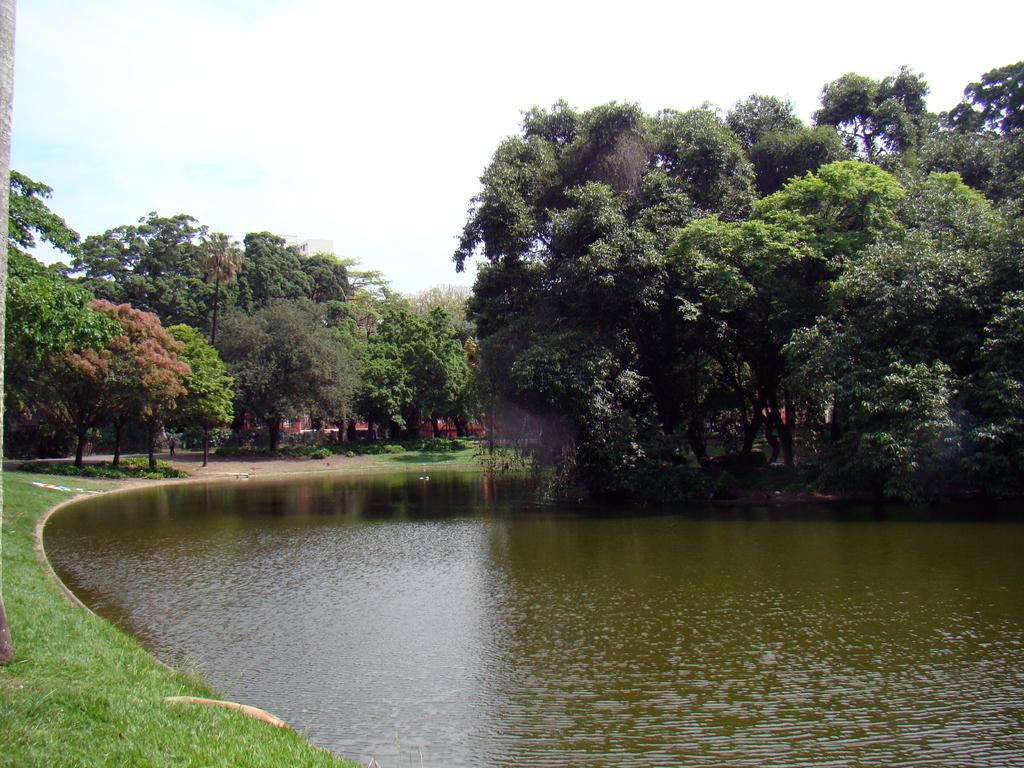What is one of the natural elements visible in the image? Water is visible in the image. What type of vegetation can be seen in the image? There is green grass in the image. What is the condition of the sky in the background? The sky is clear in the background. What type of landscape feature is visible in the background? There are trees visible in the background. What type of show is taking place in the image? There is no show present in the image; it features natural elements such as water, grass, sky, and trees. 